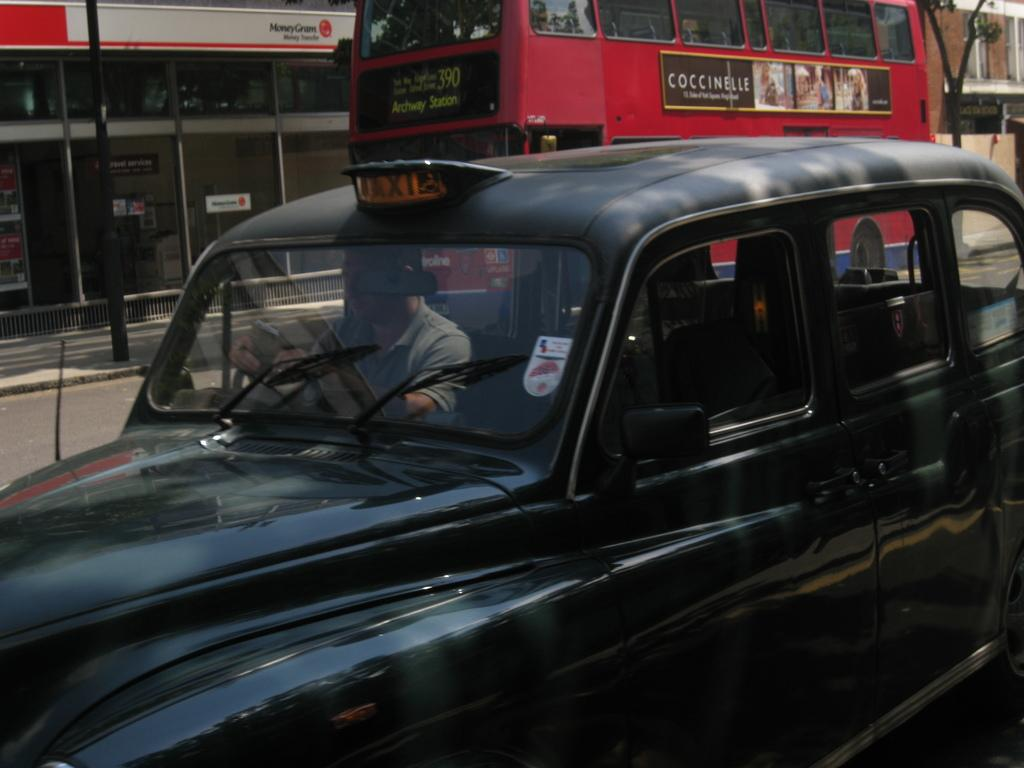Who is the main subject in the image? There is a man in the image. What is the man doing in the image? The man is riding a car. Can you describe the car in the image? The car is black. What can be seen in the background of the image? There is a bus, a building, and a tree in the background of the image. What type of kitty is sitting on the frame of the car in the image? There is no kitty present in the image, nor is there a frame around the car. 